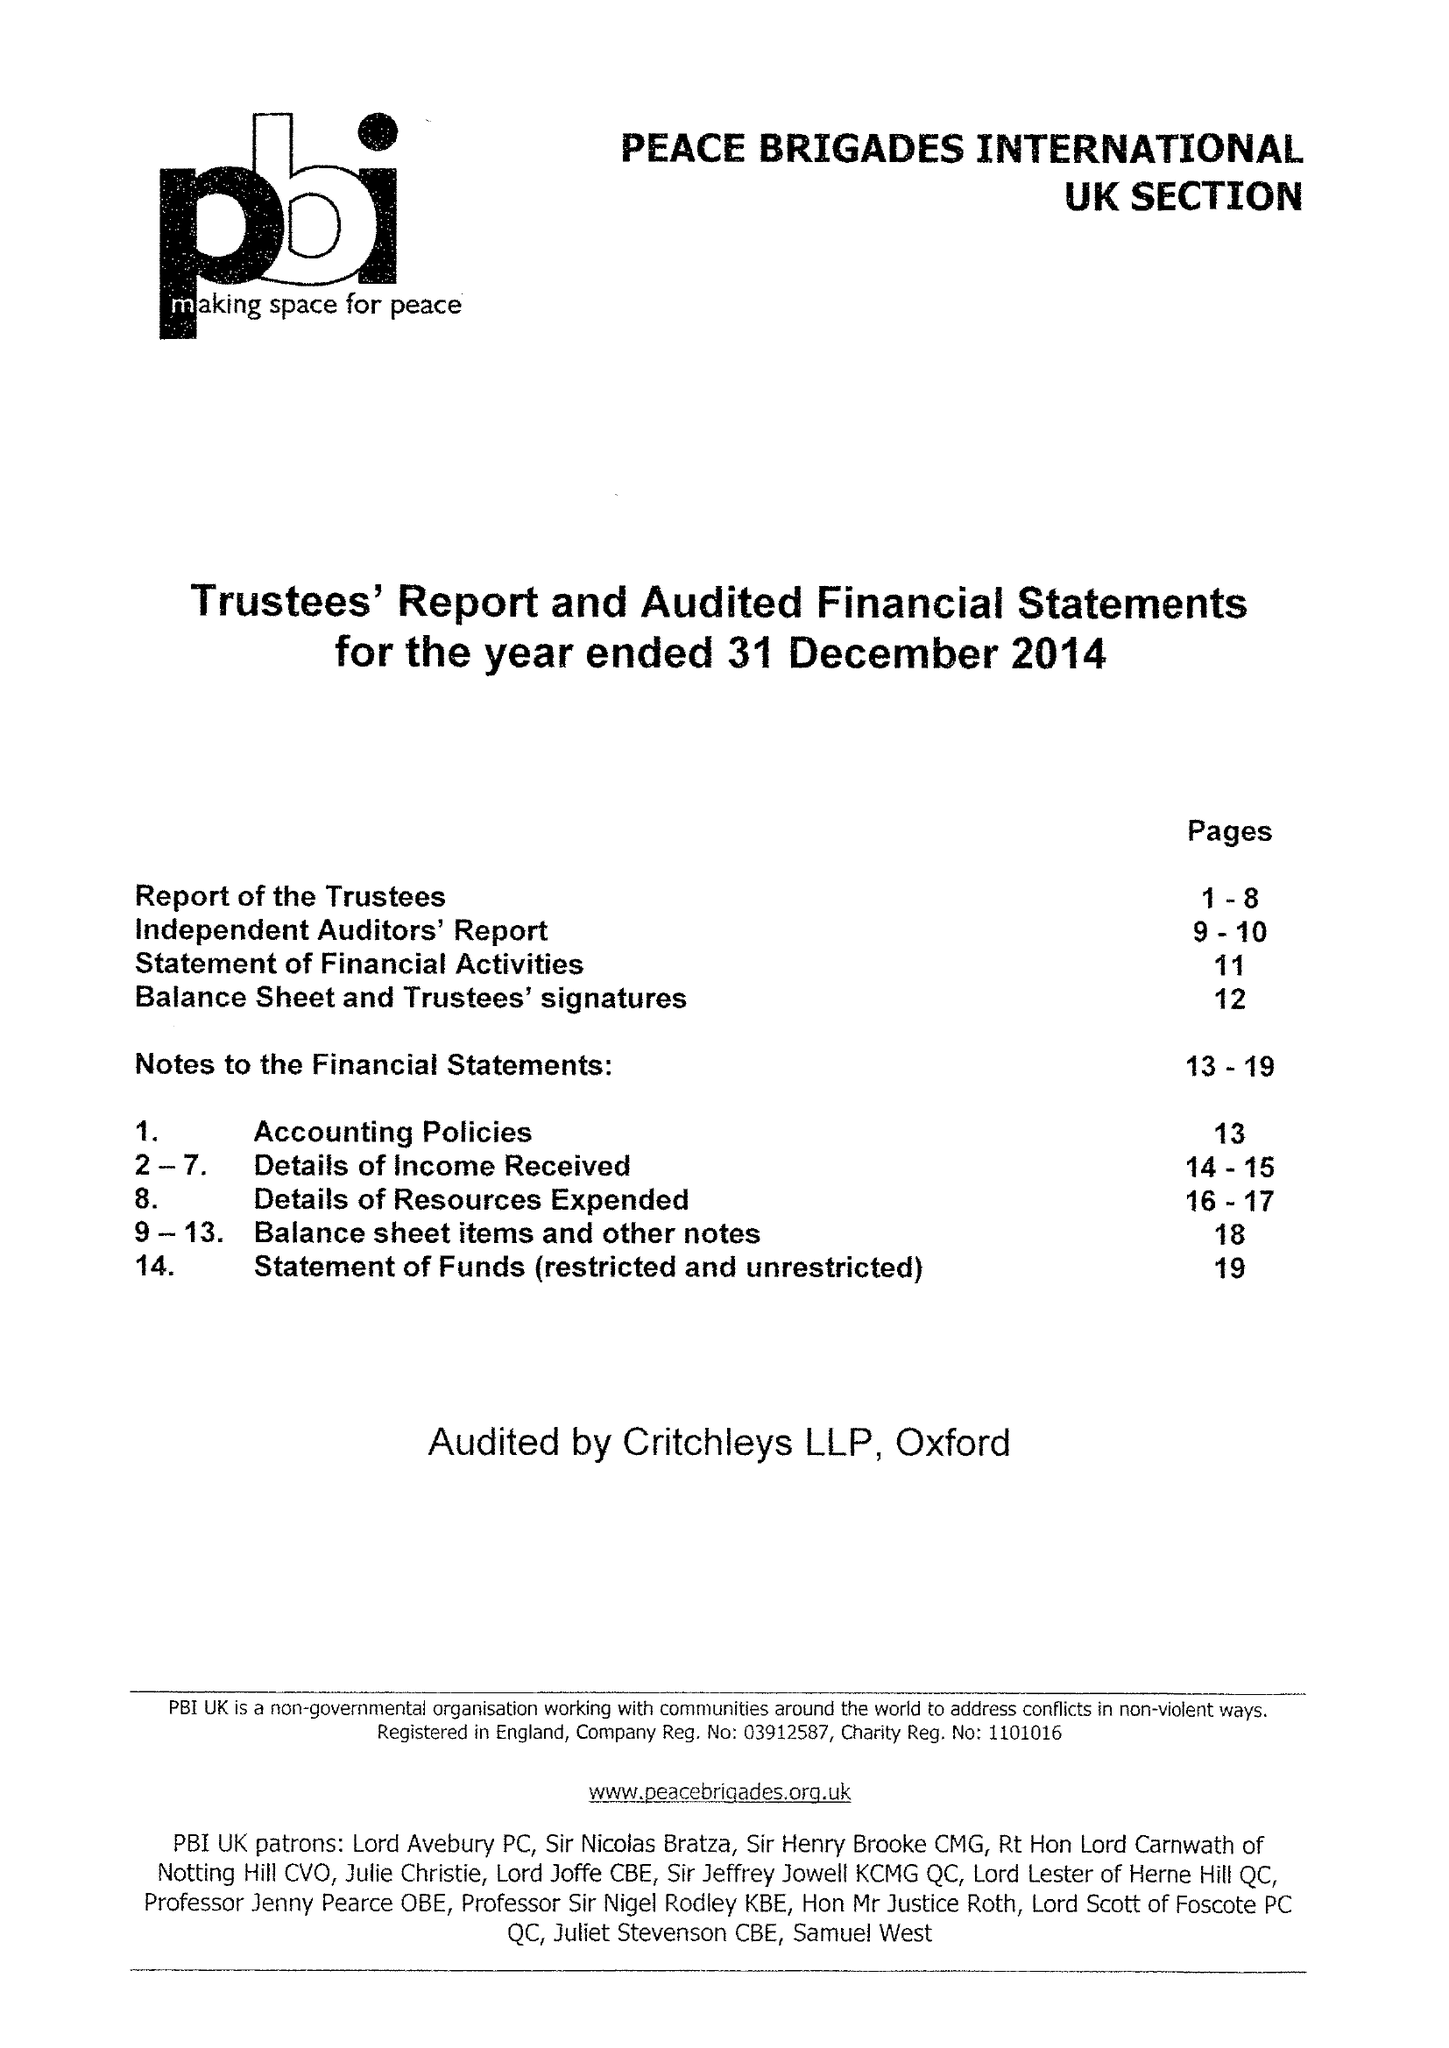What is the value for the report_date?
Answer the question using a single word or phrase. 2014-12-31 